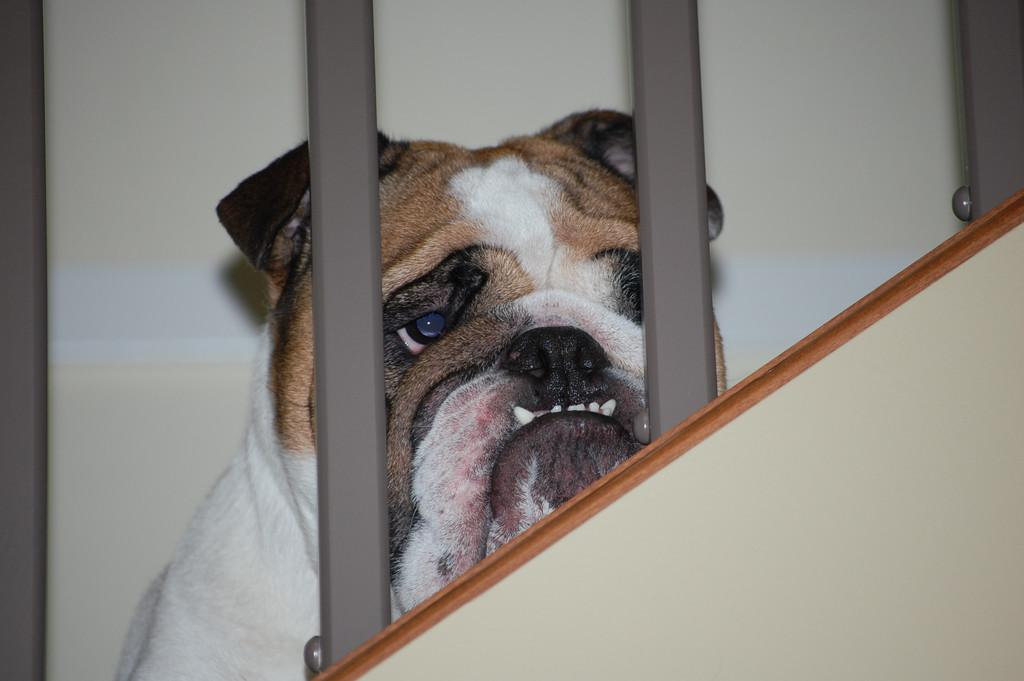What type of animal is in the image? There is a dog in the image. What colors can be seen on the dog? The dog is white and brown in color. What is the dog doing in the image? The dog appears to be sitting. What objects are in the front of the image? There are metal rods in the front of the image. Where is the dog sitting? The dog is sitting on the stairs. What can be seen in the background of the image? There is a wall in the background of the image. How many nails are visible on the dog's leg in the image? There are no nails visible on the dog's leg in the image, as dogs do not have nails on their legs like humans do. 